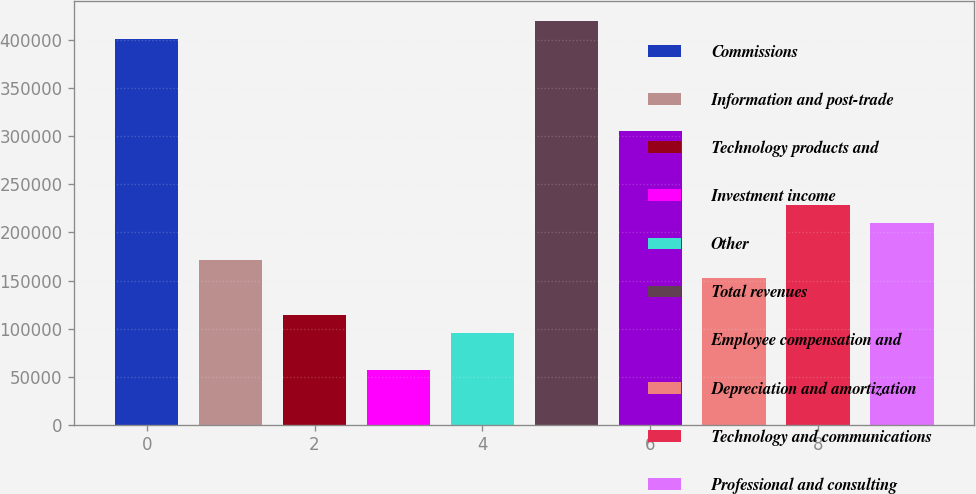<chart> <loc_0><loc_0><loc_500><loc_500><bar_chart><fcel>Commissions<fcel>Information and post-trade<fcel>Technology products and<fcel>Investment income<fcel>Other<fcel>Total revenues<fcel>Employee compensation and<fcel>Depreciation and amortization<fcel>Technology and communications<fcel>Professional and consulting<nl><fcel>400762<fcel>171756<fcel>114505<fcel>57253.2<fcel>95420.9<fcel>419846<fcel>305343<fcel>152672<fcel>229008<fcel>209924<nl></chart> 